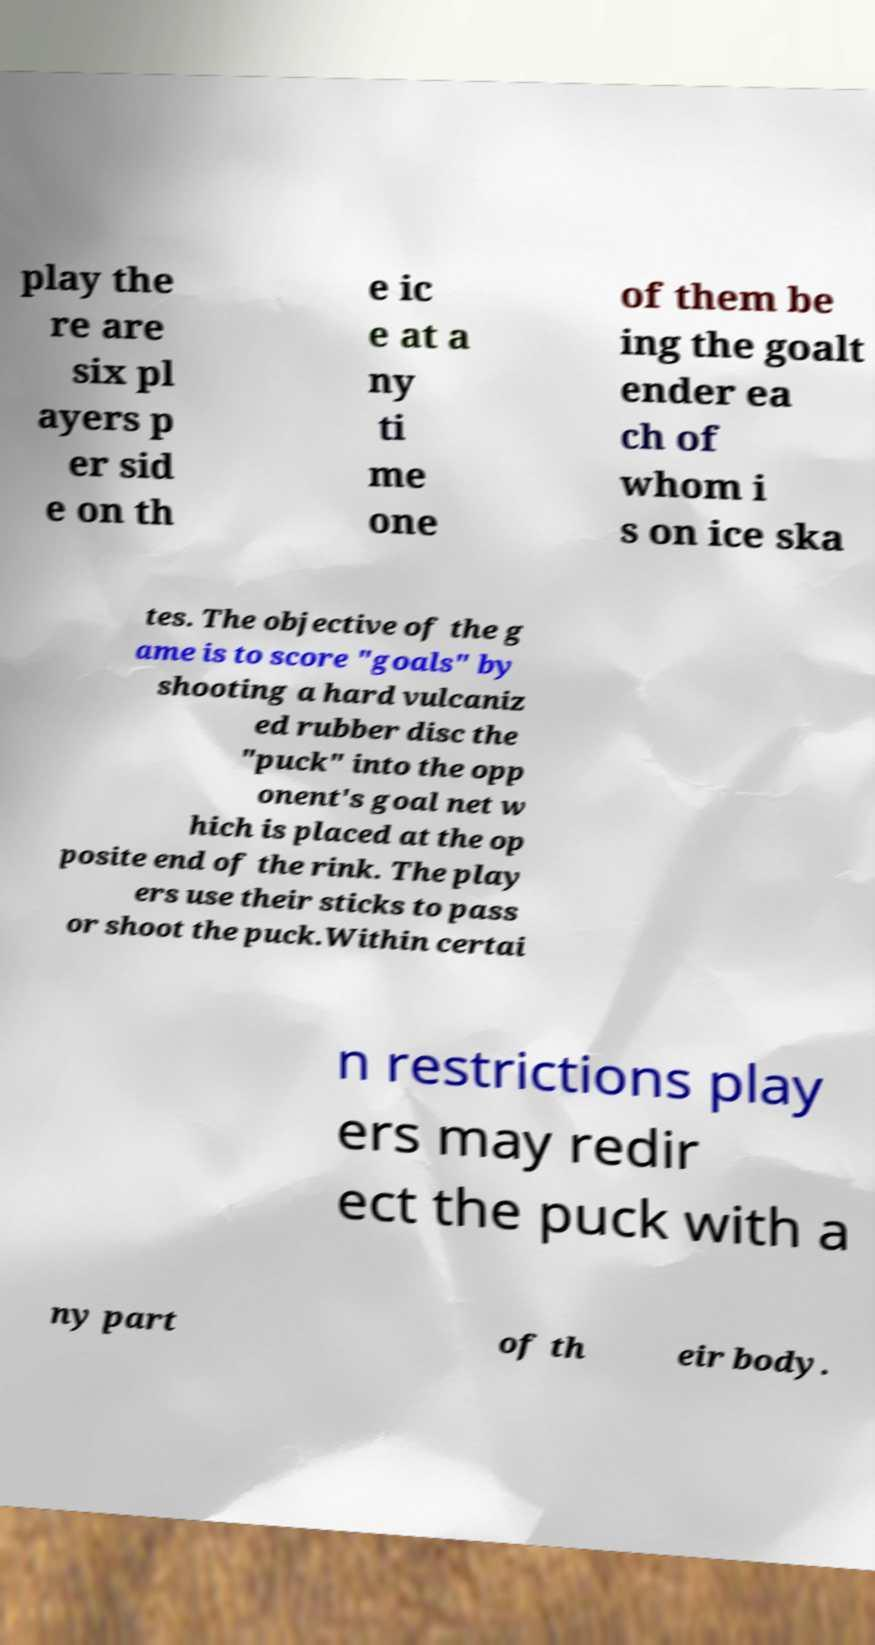Please read and relay the text visible in this image. What does it say? play the re are six pl ayers p er sid e on th e ic e at a ny ti me one of them be ing the goalt ender ea ch of whom i s on ice ska tes. The objective of the g ame is to score "goals" by shooting a hard vulcaniz ed rubber disc the "puck" into the opp onent's goal net w hich is placed at the op posite end of the rink. The play ers use their sticks to pass or shoot the puck.Within certai n restrictions play ers may redir ect the puck with a ny part of th eir body. 